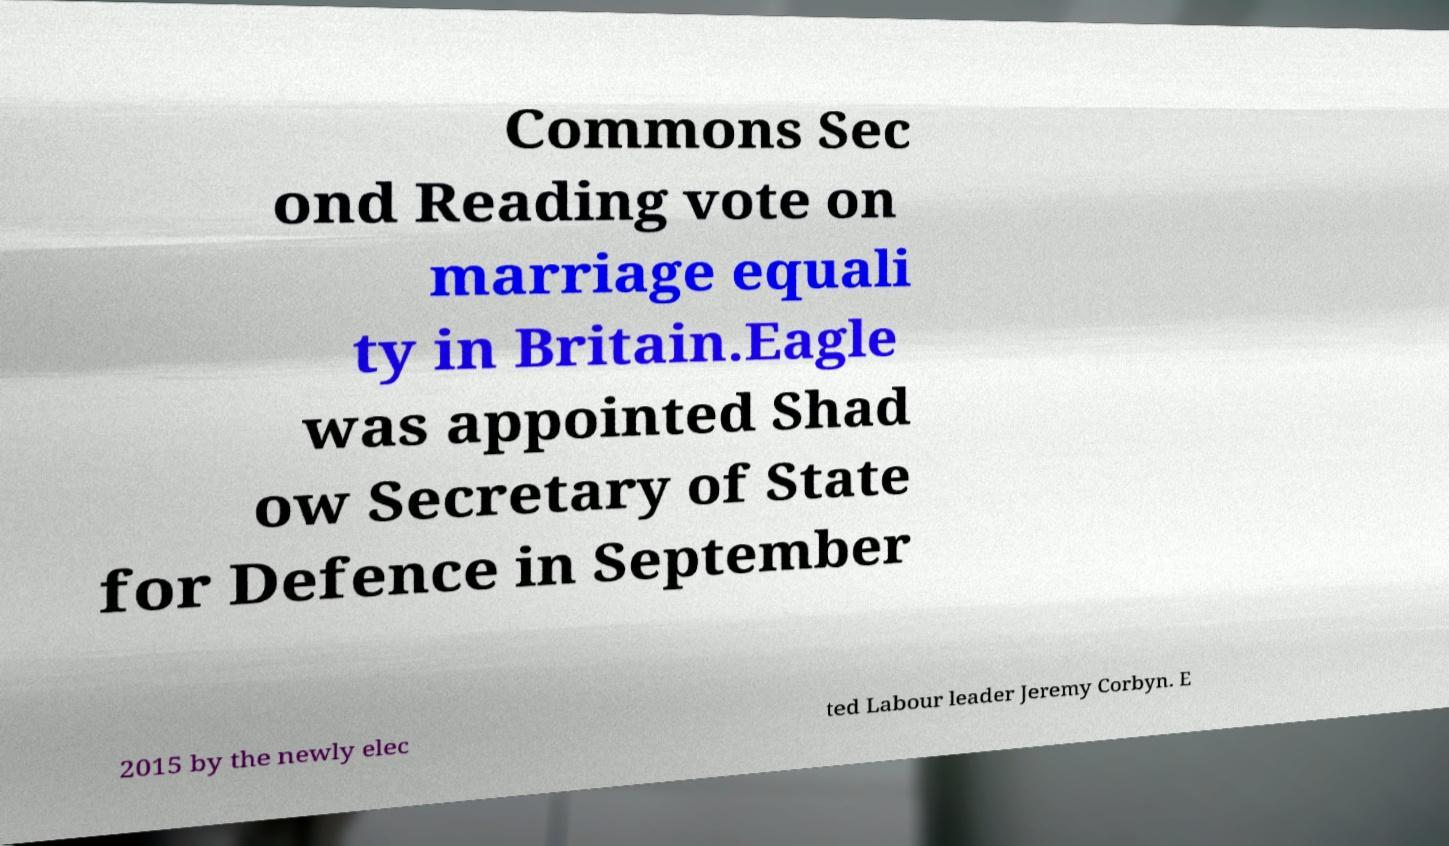Can you accurately transcribe the text from the provided image for me? Commons Sec ond Reading vote on marriage equali ty in Britain.Eagle was appointed Shad ow Secretary of State for Defence in September 2015 by the newly elec ted Labour leader Jeremy Corbyn. E 